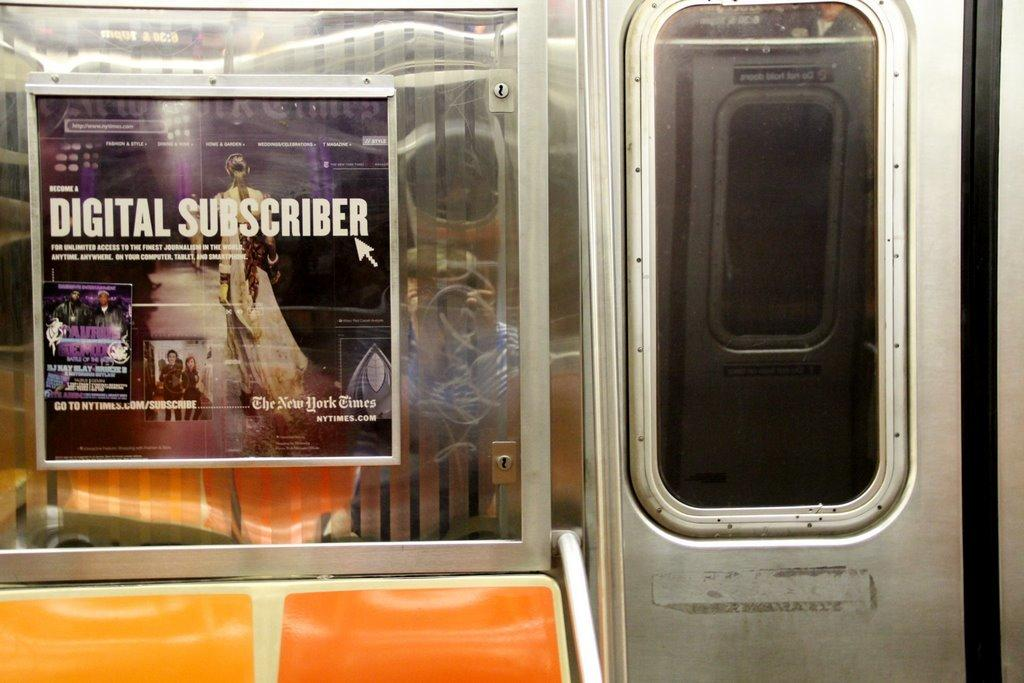What is the perspective of the image? The image is taken from inside a vehicle. What type of door can be seen in the image? There is a metal door visible in the image. Are there any openings for viewing the outside in the image? Yes, there are windows in the image. What is the board in the image used for? The purpose of the board in the image is not specified, but it is present. What color is the bench in the image? The bench in the image is orange-colored. Can you see any cobwebs in the image? There is no mention of cobwebs in the image, so it cannot be determined if they are present. Is there a fire visible in the image? There is no fire visible in the image. 